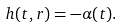<formula> <loc_0><loc_0><loc_500><loc_500>h ( t , r ) = - \alpha ( t ) .</formula> 